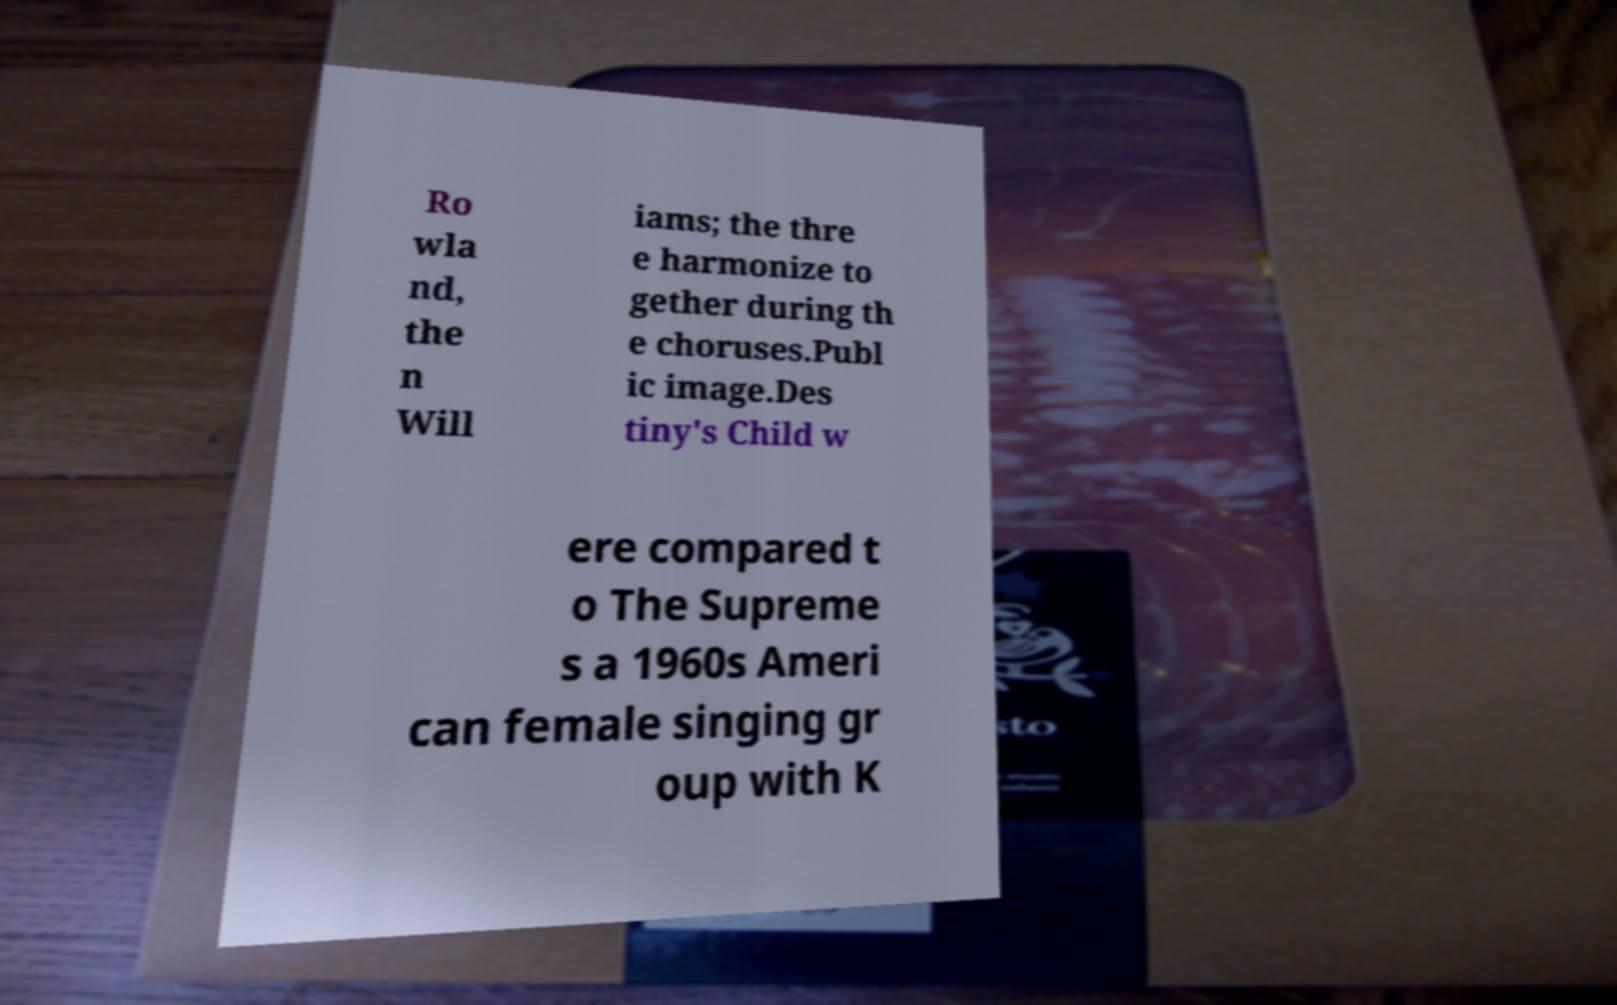Please identify and transcribe the text found in this image. Ro wla nd, the n Will iams; the thre e harmonize to gether during th e choruses.Publ ic image.Des tiny's Child w ere compared t o The Supreme s a 1960s Ameri can female singing gr oup with K 